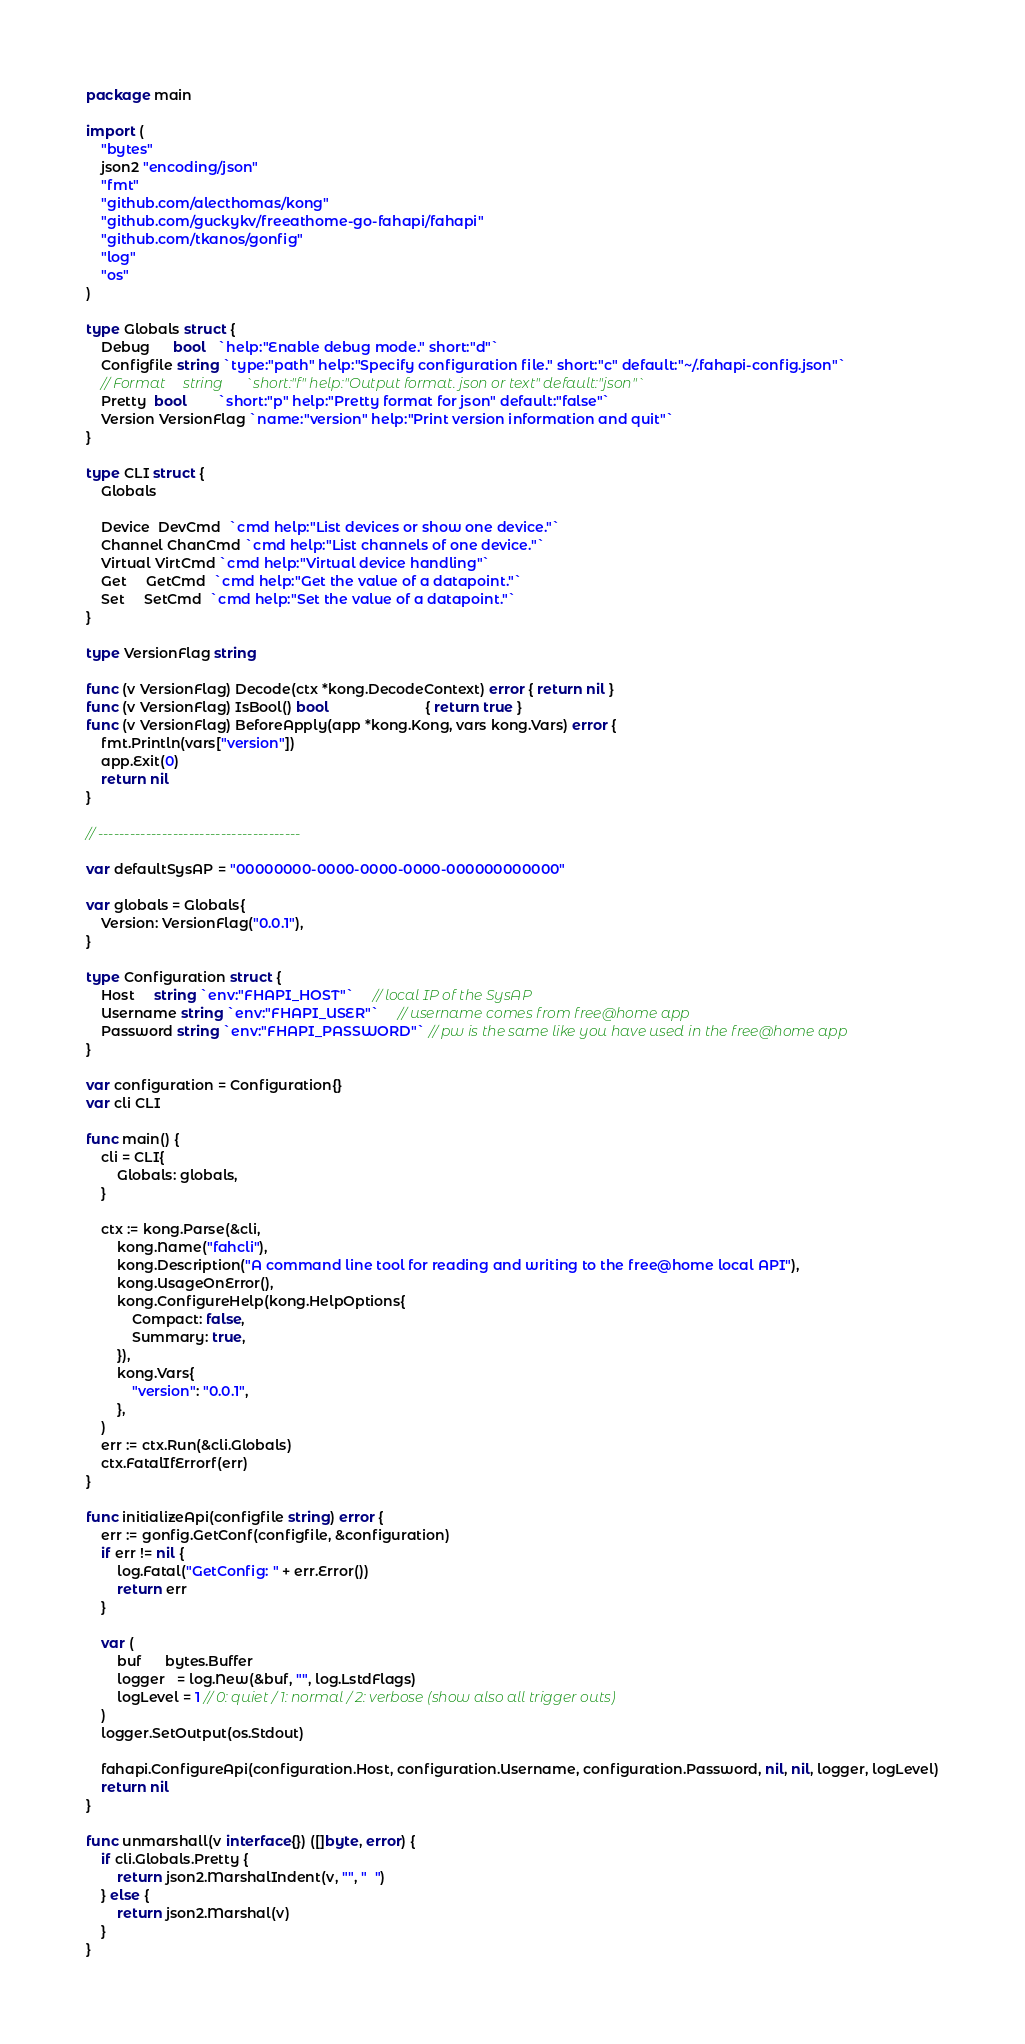<code> <loc_0><loc_0><loc_500><loc_500><_Go_>package main

import (
	"bytes"
	json2 "encoding/json"
	"fmt"
	"github.com/alecthomas/kong"
	"github.com/guckykv/freeathome-go-fahapi/fahapi"
	"github.com/tkanos/gonfig"
	"log"
	"os"
)

type Globals struct {
	Debug      bool   `help:"Enable debug mode." short:"d"`
	Configfile string `type:"path" help:"Specify configuration file." short:"c" default:"~/.fahapi-config.json"`
	// Format     string      `short:"f" help:"Output format. json or text" default:"json"`
	Pretty  bool        `short:"p" help:"Pretty format for json" default:"false"`
	Version VersionFlag `name:"version" help:"Print version information and quit"`
}

type CLI struct {
	Globals

	Device  DevCmd  `cmd help:"List devices or show one device."`
	Channel ChanCmd `cmd help:"List channels of one device."`
	Virtual VirtCmd `cmd help:"Virtual device handling"`
	Get     GetCmd  `cmd help:"Get the value of a datapoint."`
	Set     SetCmd  `cmd help:"Set the value of a datapoint."`
}

type VersionFlag string

func (v VersionFlag) Decode(ctx *kong.DecodeContext) error { return nil }
func (v VersionFlag) IsBool() bool                         { return true }
func (v VersionFlag) BeforeApply(app *kong.Kong, vars kong.Vars) error {
	fmt.Println(vars["version"])
	app.Exit(0)
	return nil
}

// --------------------------------------

var defaultSysAP = "00000000-0000-0000-0000-000000000000"

var globals = Globals{
	Version: VersionFlag("0.0.1"),
}

type Configuration struct {
	Host     string `env:"FHAPI_HOST"`     // local IP of the SysAP
	Username string `env:"FHAPI_USER"`     // username comes from free@home app
	Password string `env:"FHAPI_PASSWORD"` // pw is the same like you have used in the free@home app
}

var configuration = Configuration{}
var cli CLI

func main() {
	cli = CLI{
		Globals: globals,
	}

	ctx := kong.Parse(&cli,
		kong.Name("fahcli"),
		kong.Description("A command line tool for reading and writing to the free@home local API"),
		kong.UsageOnError(),
		kong.ConfigureHelp(kong.HelpOptions{
			Compact: false,
			Summary: true,
		}),
		kong.Vars{
			"version": "0.0.1",
		},
	)
	err := ctx.Run(&cli.Globals)
	ctx.FatalIfErrorf(err)
}

func initializeApi(configfile string) error {
	err := gonfig.GetConf(configfile, &configuration)
	if err != nil {
		log.Fatal("GetConfig: " + err.Error())
		return err
	}

	var (
		buf      bytes.Buffer
		logger   = log.New(&buf, "", log.LstdFlags)
		logLevel = 1 // 0: quiet / 1: normal / 2: verbose (show also all trigger outs)
	)
	logger.SetOutput(os.Stdout)

	fahapi.ConfigureApi(configuration.Host, configuration.Username, configuration.Password, nil, nil, logger, logLevel)
	return nil
}

func unmarshall(v interface{}) ([]byte, error) {
	if cli.Globals.Pretty {
		return json2.MarshalIndent(v, "", "  ")
	} else {
		return json2.Marshal(v)
	}
}
</code> 